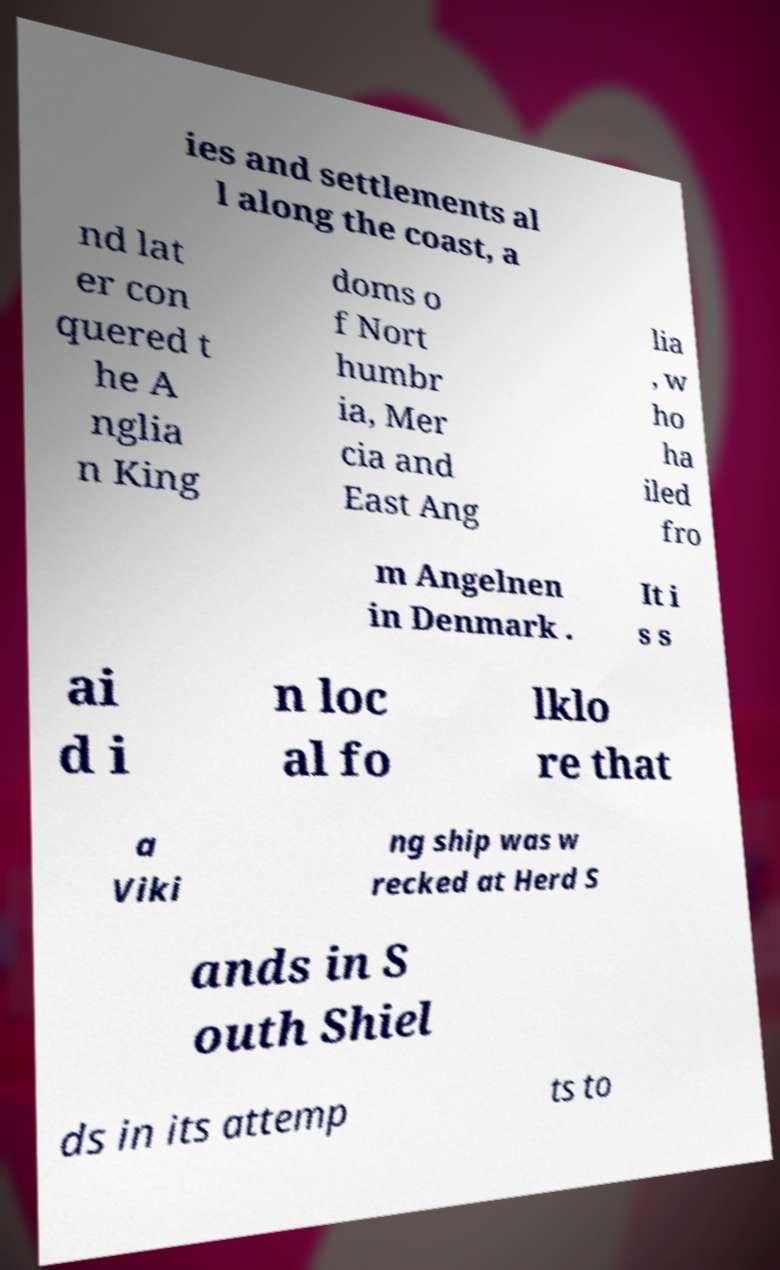Can you accurately transcribe the text from the provided image for me? ies and settlements al l along the coast, a nd lat er con quered t he A nglia n King doms o f Nort humbr ia, Mer cia and East Ang lia , w ho ha iled fro m Angelnen in Denmark . It i s s ai d i n loc al fo lklo re that a Viki ng ship was w recked at Herd S ands in S outh Shiel ds in its attemp ts to 